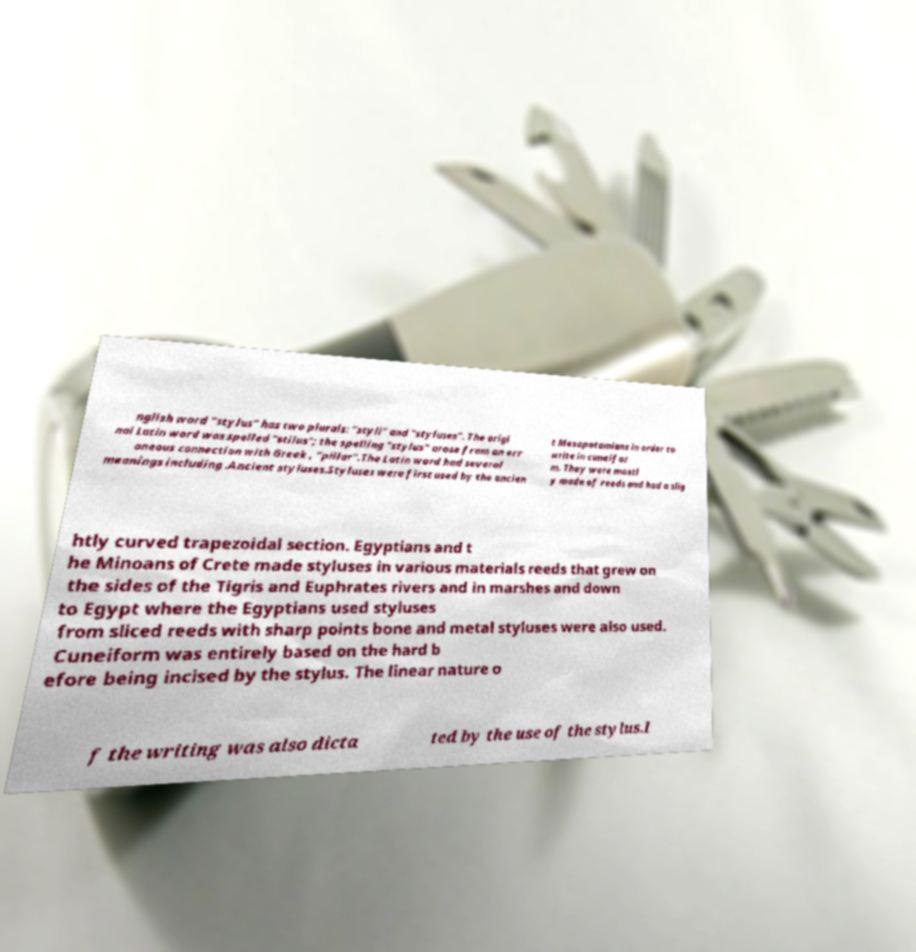Please read and relay the text visible in this image. What does it say? nglish word "stylus" has two plurals: "styli" and "styluses". The origi nal Latin word was spelled "stilus"; the spelling "stylus" arose from an err oneous connection with Greek , "pillar".The Latin word had several meanings including .Ancient styluses.Styluses were first used by the ancien t Mesopotamians in order to write in cuneifor m. They were mostl y made of reeds and had a slig htly curved trapezoidal section. Egyptians and t he Minoans of Crete made styluses in various materials reeds that grew on the sides of the Tigris and Euphrates rivers and in marshes and down to Egypt where the Egyptians used styluses from sliced reeds with sharp points bone and metal styluses were also used. Cuneiform was entirely based on the hard b efore being incised by the stylus. The linear nature o f the writing was also dicta ted by the use of the stylus.I 